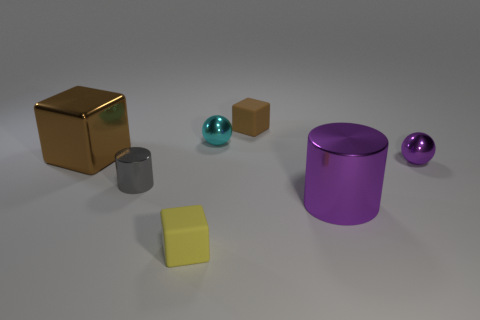Add 3 cubes. How many objects exist? 10 Subtract all cylinders. How many objects are left? 5 Subtract 0 red cubes. How many objects are left? 7 Subtract all tiny brown objects. Subtract all small purple balls. How many objects are left? 5 Add 3 purple things. How many purple things are left? 5 Add 2 brown things. How many brown things exist? 4 